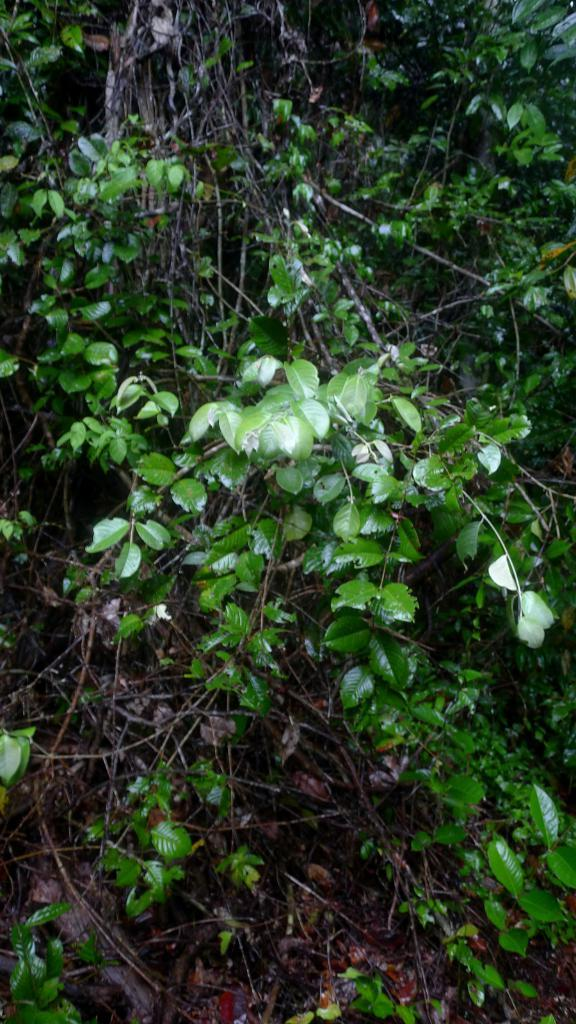What type of living organisms can be seen in the image? Plants can be seen in the image. What can be found at the bottom of the image? Dry leaves and the ground are visible at the bottom of the image. Can you describe the ground in the image? The ground is visible at the bottom of the image. What type of respectful vessel is being used to talk in the image? There is no vessel or conversation present in the image; it only features plants and the ground. 